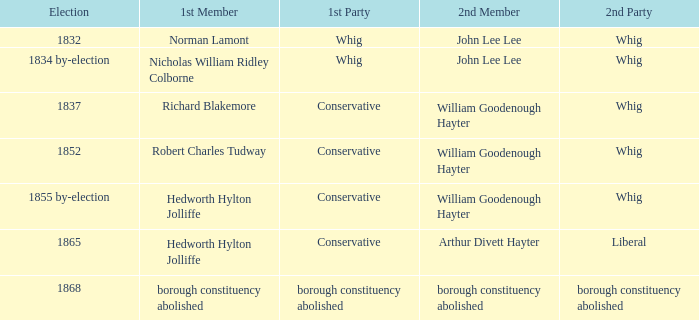What election has a 1st member of richard blakemore and a 2nd member of william goodenough hayter? 1837.0. 